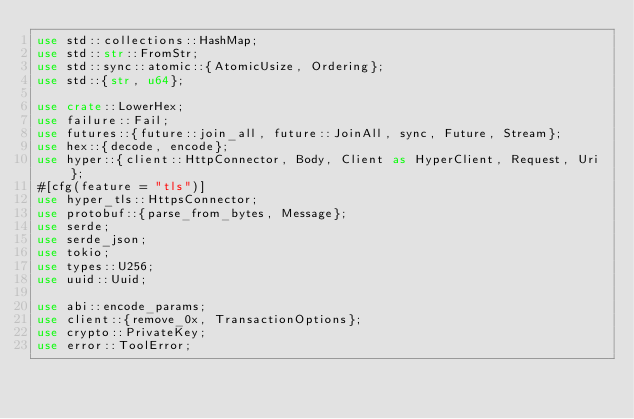Convert code to text. <code><loc_0><loc_0><loc_500><loc_500><_Rust_>use std::collections::HashMap;
use std::str::FromStr;
use std::sync::atomic::{AtomicUsize, Ordering};
use std::{str, u64};

use crate::LowerHex;
use failure::Fail;
use futures::{future::join_all, future::JoinAll, sync, Future, Stream};
use hex::{decode, encode};
use hyper::{client::HttpConnector, Body, Client as HyperClient, Request, Uri};
#[cfg(feature = "tls")]
use hyper_tls::HttpsConnector;
use protobuf::{parse_from_bytes, Message};
use serde;
use serde_json;
use tokio;
use types::U256;
use uuid::Uuid;

use abi::encode_params;
use client::{remove_0x, TransactionOptions};
use crypto::PrivateKey;
use error::ToolError;</code> 